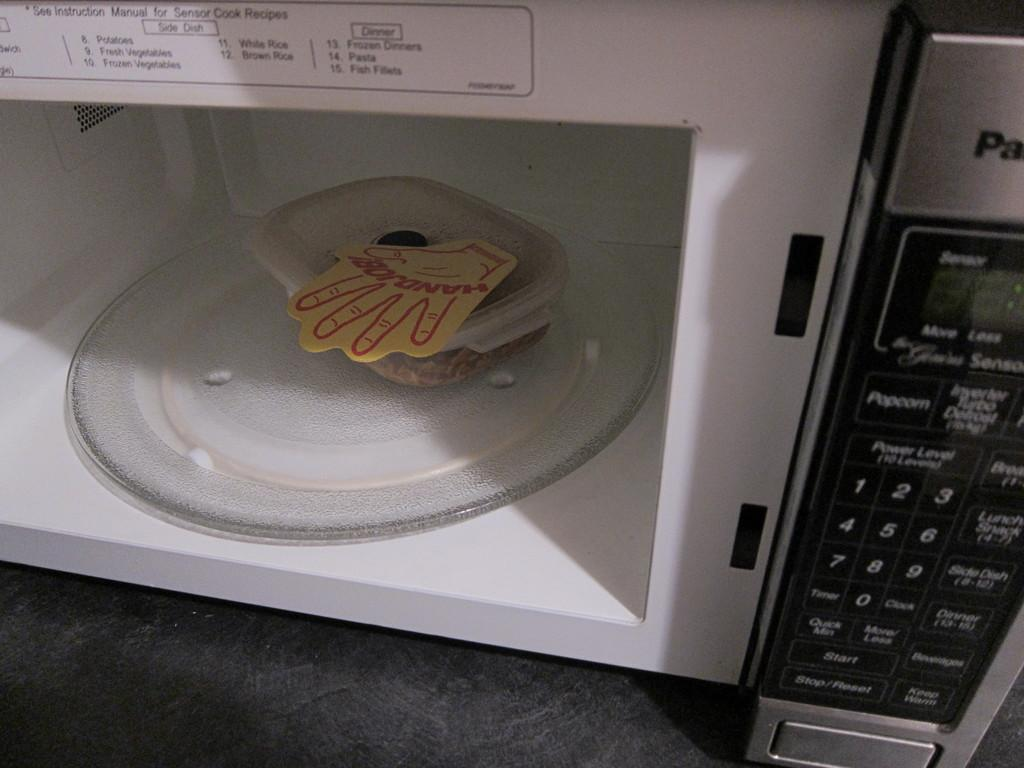What object is present in the image? There is a container in the image. Where is the container located? The container is inside a microwave. What can be seen on the right side of the image? There are buttons visible on the right side of the image. What type of church is depicted in the image? There is no church present in the image; it features a container inside a microwave and buttons on the right side. 